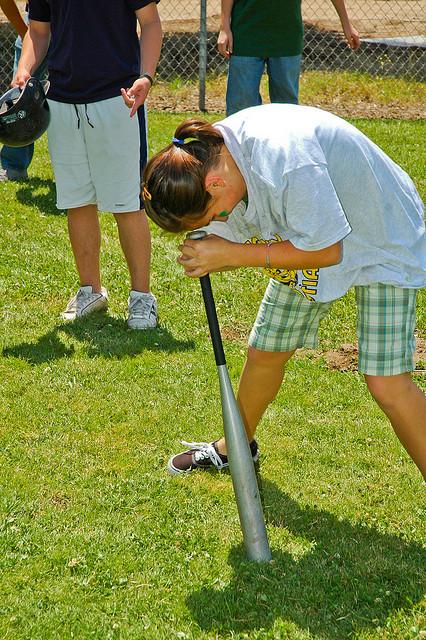What sport is this girl playing?
Concise answer only. Baseball. Is there a helmet in the picture?
Concise answer only. No. What is that bat made out of?
Be succinct. Aluminum. 